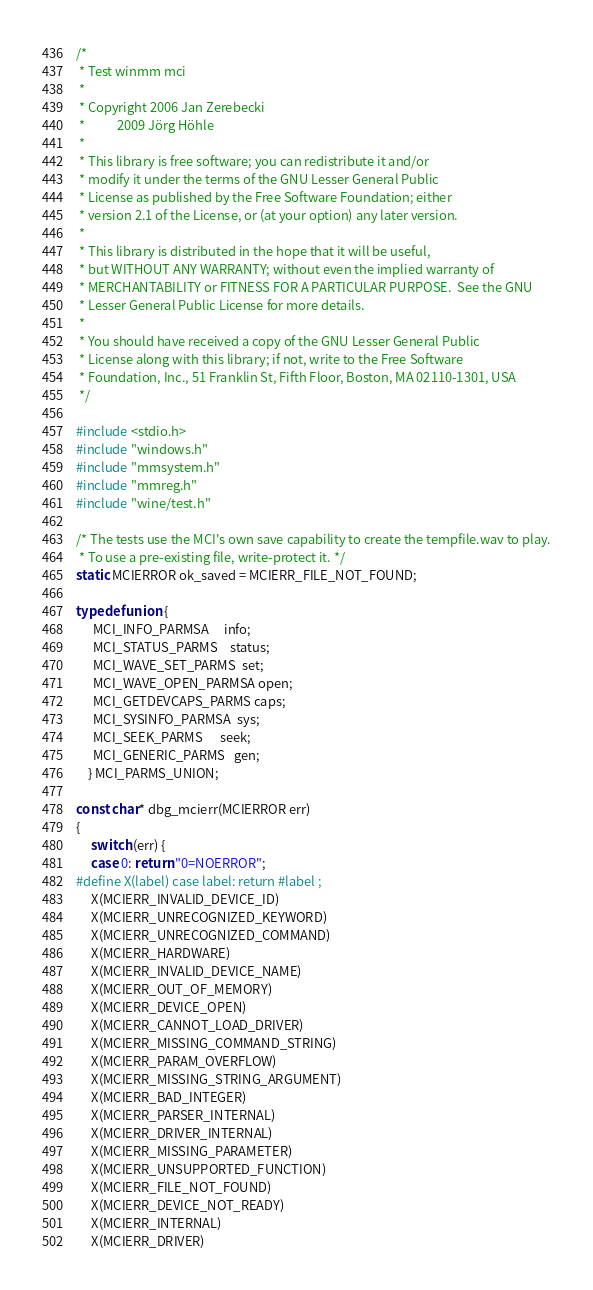<code> <loc_0><loc_0><loc_500><loc_500><_C_>/*
 * Test winmm mci
 *
 * Copyright 2006 Jan Zerebecki
 *           2009 Jörg Höhle
 *
 * This library is free software; you can redistribute it and/or
 * modify it under the terms of the GNU Lesser General Public
 * License as published by the Free Software Foundation; either
 * version 2.1 of the License, or (at your option) any later version.
 *
 * This library is distributed in the hope that it will be useful,
 * but WITHOUT ANY WARRANTY; without even the implied warranty of
 * MERCHANTABILITY or FITNESS FOR A PARTICULAR PURPOSE.  See the GNU
 * Lesser General Public License for more details.
 *
 * You should have received a copy of the GNU Lesser General Public
 * License along with this library; if not, write to the Free Software
 * Foundation, Inc., 51 Franklin St, Fifth Floor, Boston, MA 02110-1301, USA
 */

#include <stdio.h>
#include "windows.h"
#include "mmsystem.h"
#include "mmreg.h"
#include "wine/test.h"

/* The tests use the MCI's own save capability to create the tempfile.wav to play.
 * To use a pre-existing file, write-protect it. */
static MCIERROR ok_saved = MCIERR_FILE_NOT_FOUND;

typedef union {
      MCI_INFO_PARMSA     info;
      MCI_STATUS_PARMS    status;
      MCI_WAVE_SET_PARMS  set;
      MCI_WAVE_OPEN_PARMSA open;
      MCI_GETDEVCAPS_PARMS caps;
      MCI_SYSINFO_PARMSA  sys;
      MCI_SEEK_PARMS      seek;
      MCI_GENERIC_PARMS   gen;
    } MCI_PARMS_UNION;

const char* dbg_mcierr(MCIERROR err)
{
     switch (err) {
     case 0: return "0=NOERROR";
#define X(label) case label: return #label ;
     X(MCIERR_INVALID_DEVICE_ID)
     X(MCIERR_UNRECOGNIZED_KEYWORD)
     X(MCIERR_UNRECOGNIZED_COMMAND)
     X(MCIERR_HARDWARE)
     X(MCIERR_INVALID_DEVICE_NAME)
     X(MCIERR_OUT_OF_MEMORY)
     X(MCIERR_DEVICE_OPEN)
     X(MCIERR_CANNOT_LOAD_DRIVER)
     X(MCIERR_MISSING_COMMAND_STRING)
     X(MCIERR_PARAM_OVERFLOW)
     X(MCIERR_MISSING_STRING_ARGUMENT)
     X(MCIERR_BAD_INTEGER)
     X(MCIERR_PARSER_INTERNAL)
     X(MCIERR_DRIVER_INTERNAL)
     X(MCIERR_MISSING_PARAMETER)
     X(MCIERR_UNSUPPORTED_FUNCTION)
     X(MCIERR_FILE_NOT_FOUND)
     X(MCIERR_DEVICE_NOT_READY)
     X(MCIERR_INTERNAL)
     X(MCIERR_DRIVER)</code> 